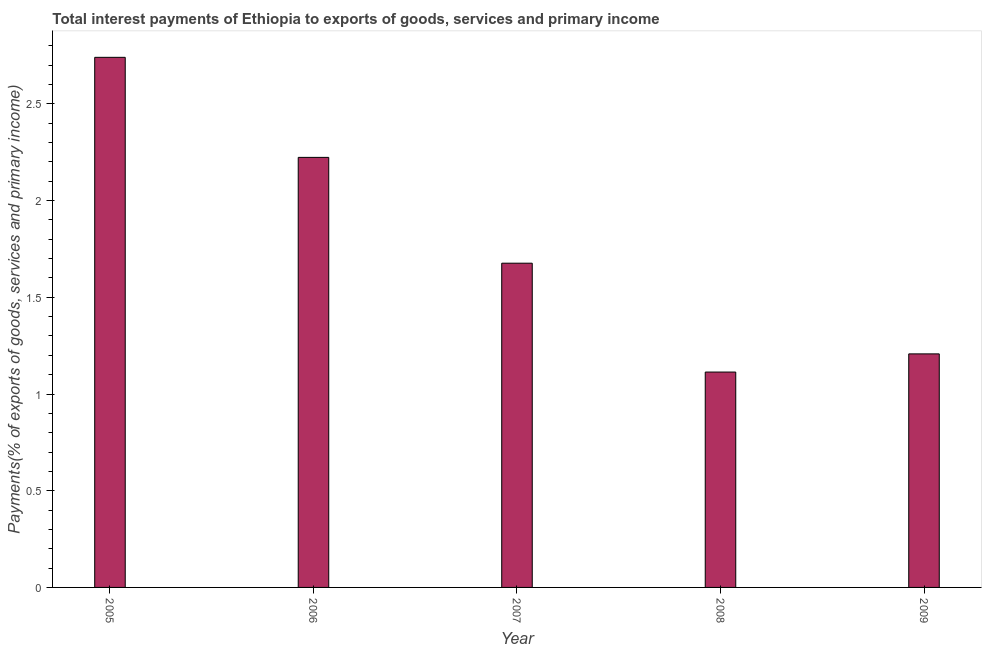What is the title of the graph?
Ensure brevity in your answer.  Total interest payments of Ethiopia to exports of goods, services and primary income. What is the label or title of the X-axis?
Your answer should be very brief. Year. What is the label or title of the Y-axis?
Your response must be concise. Payments(% of exports of goods, services and primary income). What is the total interest payments on external debt in 2008?
Your response must be concise. 1.11. Across all years, what is the maximum total interest payments on external debt?
Keep it short and to the point. 2.74. Across all years, what is the minimum total interest payments on external debt?
Ensure brevity in your answer.  1.11. In which year was the total interest payments on external debt maximum?
Your answer should be compact. 2005. What is the sum of the total interest payments on external debt?
Ensure brevity in your answer.  8.96. What is the difference between the total interest payments on external debt in 2006 and 2007?
Your response must be concise. 0.55. What is the average total interest payments on external debt per year?
Give a very brief answer. 1.79. What is the median total interest payments on external debt?
Your answer should be very brief. 1.68. In how many years, is the total interest payments on external debt greater than 2.3 %?
Your answer should be compact. 1. What is the ratio of the total interest payments on external debt in 2005 to that in 2009?
Provide a succinct answer. 2.27. Is the total interest payments on external debt in 2006 less than that in 2007?
Give a very brief answer. No. Is the difference between the total interest payments on external debt in 2005 and 2009 greater than the difference between any two years?
Make the answer very short. No. What is the difference between the highest and the second highest total interest payments on external debt?
Offer a very short reply. 0.52. Is the sum of the total interest payments on external debt in 2005 and 2009 greater than the maximum total interest payments on external debt across all years?
Provide a short and direct response. Yes. What is the difference between the highest and the lowest total interest payments on external debt?
Ensure brevity in your answer.  1.63. In how many years, is the total interest payments on external debt greater than the average total interest payments on external debt taken over all years?
Provide a succinct answer. 2. Are the values on the major ticks of Y-axis written in scientific E-notation?
Keep it short and to the point. No. What is the Payments(% of exports of goods, services and primary income) in 2005?
Ensure brevity in your answer.  2.74. What is the Payments(% of exports of goods, services and primary income) of 2006?
Your response must be concise. 2.22. What is the Payments(% of exports of goods, services and primary income) of 2007?
Provide a succinct answer. 1.68. What is the Payments(% of exports of goods, services and primary income) of 2008?
Provide a succinct answer. 1.11. What is the Payments(% of exports of goods, services and primary income) in 2009?
Provide a short and direct response. 1.21. What is the difference between the Payments(% of exports of goods, services and primary income) in 2005 and 2006?
Your response must be concise. 0.52. What is the difference between the Payments(% of exports of goods, services and primary income) in 2005 and 2007?
Your response must be concise. 1.06. What is the difference between the Payments(% of exports of goods, services and primary income) in 2005 and 2008?
Ensure brevity in your answer.  1.63. What is the difference between the Payments(% of exports of goods, services and primary income) in 2005 and 2009?
Offer a terse response. 1.53. What is the difference between the Payments(% of exports of goods, services and primary income) in 2006 and 2007?
Offer a terse response. 0.55. What is the difference between the Payments(% of exports of goods, services and primary income) in 2006 and 2008?
Keep it short and to the point. 1.11. What is the difference between the Payments(% of exports of goods, services and primary income) in 2006 and 2009?
Provide a short and direct response. 1.02. What is the difference between the Payments(% of exports of goods, services and primary income) in 2007 and 2008?
Keep it short and to the point. 0.56. What is the difference between the Payments(% of exports of goods, services and primary income) in 2007 and 2009?
Your answer should be very brief. 0.47. What is the difference between the Payments(% of exports of goods, services and primary income) in 2008 and 2009?
Ensure brevity in your answer.  -0.09. What is the ratio of the Payments(% of exports of goods, services and primary income) in 2005 to that in 2006?
Provide a short and direct response. 1.23. What is the ratio of the Payments(% of exports of goods, services and primary income) in 2005 to that in 2007?
Offer a very short reply. 1.64. What is the ratio of the Payments(% of exports of goods, services and primary income) in 2005 to that in 2008?
Ensure brevity in your answer.  2.46. What is the ratio of the Payments(% of exports of goods, services and primary income) in 2005 to that in 2009?
Your response must be concise. 2.27. What is the ratio of the Payments(% of exports of goods, services and primary income) in 2006 to that in 2007?
Offer a terse response. 1.33. What is the ratio of the Payments(% of exports of goods, services and primary income) in 2006 to that in 2008?
Offer a very short reply. 2. What is the ratio of the Payments(% of exports of goods, services and primary income) in 2006 to that in 2009?
Ensure brevity in your answer.  1.84. What is the ratio of the Payments(% of exports of goods, services and primary income) in 2007 to that in 2008?
Give a very brief answer. 1.5. What is the ratio of the Payments(% of exports of goods, services and primary income) in 2007 to that in 2009?
Ensure brevity in your answer.  1.39. What is the ratio of the Payments(% of exports of goods, services and primary income) in 2008 to that in 2009?
Give a very brief answer. 0.92. 